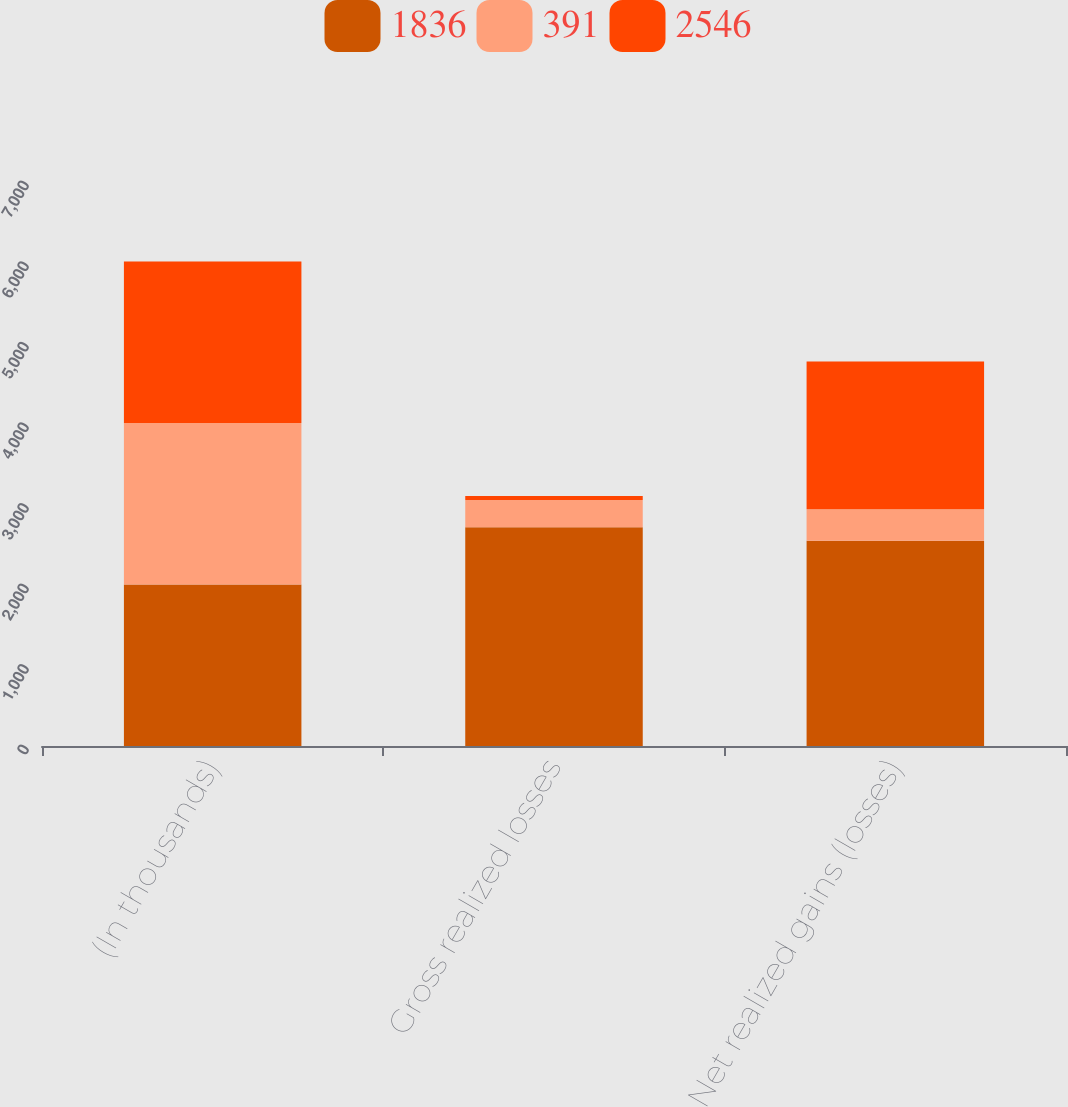Convert chart. <chart><loc_0><loc_0><loc_500><loc_500><stacked_bar_chart><ecel><fcel>(In thousands)<fcel>Gross realized losses<fcel>Net realized gains (losses)<nl><fcel>1836<fcel>2005<fcel>2716<fcel>2546<nl><fcel>391<fcel>2004<fcel>337<fcel>391<nl><fcel>2546<fcel>2003<fcel>49<fcel>1836<nl></chart> 